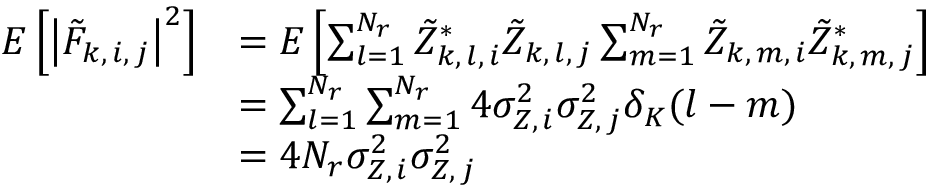<formula> <loc_0><loc_0><loc_500><loc_500>\begin{array} { r l } { E \left [ \left | \tilde { F } _ { k , \, i , \, j } \right | ^ { 2 } \right ] } & { = E \left [ \sum _ { l = 1 } ^ { N _ { r } } \tilde { Z } _ { k , \, l , \, i } ^ { * } \tilde { Z } _ { k , \, l , \, j } \sum _ { m = 1 } ^ { N _ { r } } \tilde { Z } _ { k , \, m , \, i } \tilde { Z } _ { k , \, m , \, j } ^ { * } \right ] } \\ & { = \sum _ { l = 1 } ^ { N _ { r } } \sum _ { m = 1 } ^ { N _ { r } } 4 \sigma _ { Z , \, i } ^ { 2 } \sigma _ { Z , \, j } ^ { 2 } \delta _ { K } ( l - m ) } \\ & { = 4 N _ { r } \sigma _ { Z , \, i } ^ { 2 } \sigma _ { Z , \, j } ^ { 2 } } \end{array}</formula> 